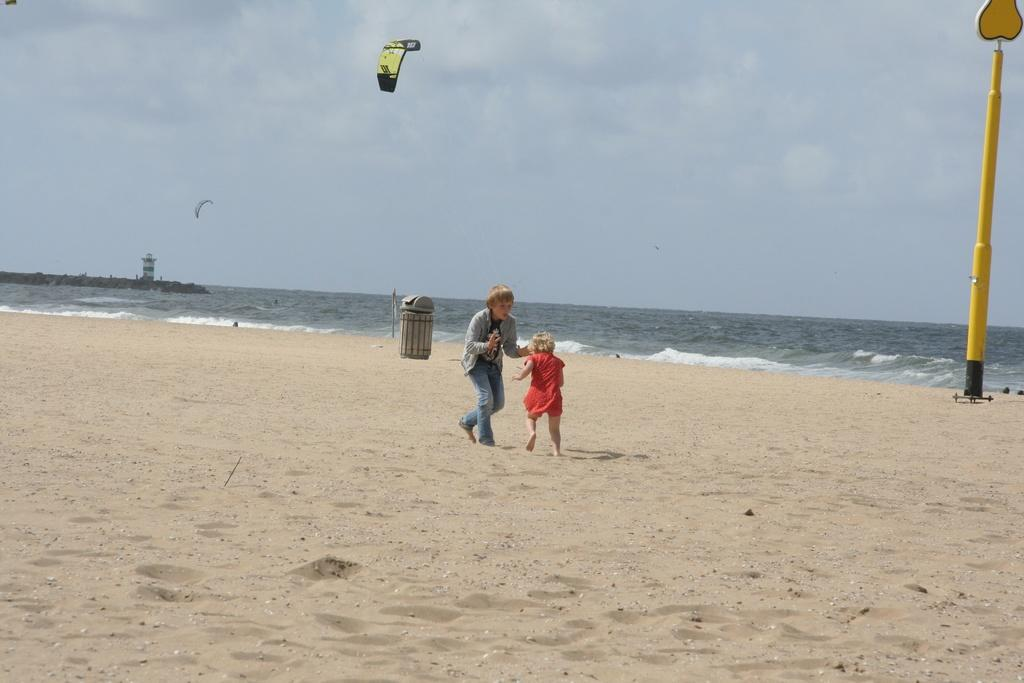What can be found in the image that is used for waste disposal? There is a bin in the image that is used for waste disposal. Who is present in the image besides the bin? There are children in the image. What type of terrain is visible in the image? Sand is present in the image, suggesting a beach or sandy area. What is the weather like in the image? The sky appears to be cloudy in the image. What activity is taking place in the image? Paragliding is occurring in the image. What structure can be seen in the image? There is a tower in the image. What is the purpose of the pole in the image? The pole's purpose is not clear from the image, but it could be used for various purposes such as signage or supporting equipment. What is the board used for in the image? The board's purpose is not clear from the image, but it could be used for various purposes such as a sign or a platform. What other objects can be seen in the image? There are various objects in the image, but their specific purposes are not clear from the provided facts. How many frogs are hopping on the board in the image? There are no frogs present in the image. What direction is the current flowing in the image? There is no water current visible in the image. What type of sponge is being used to clean the bin in the image? There is no sponge present in the image, and the bin does not appear to be in need of cleaning. 